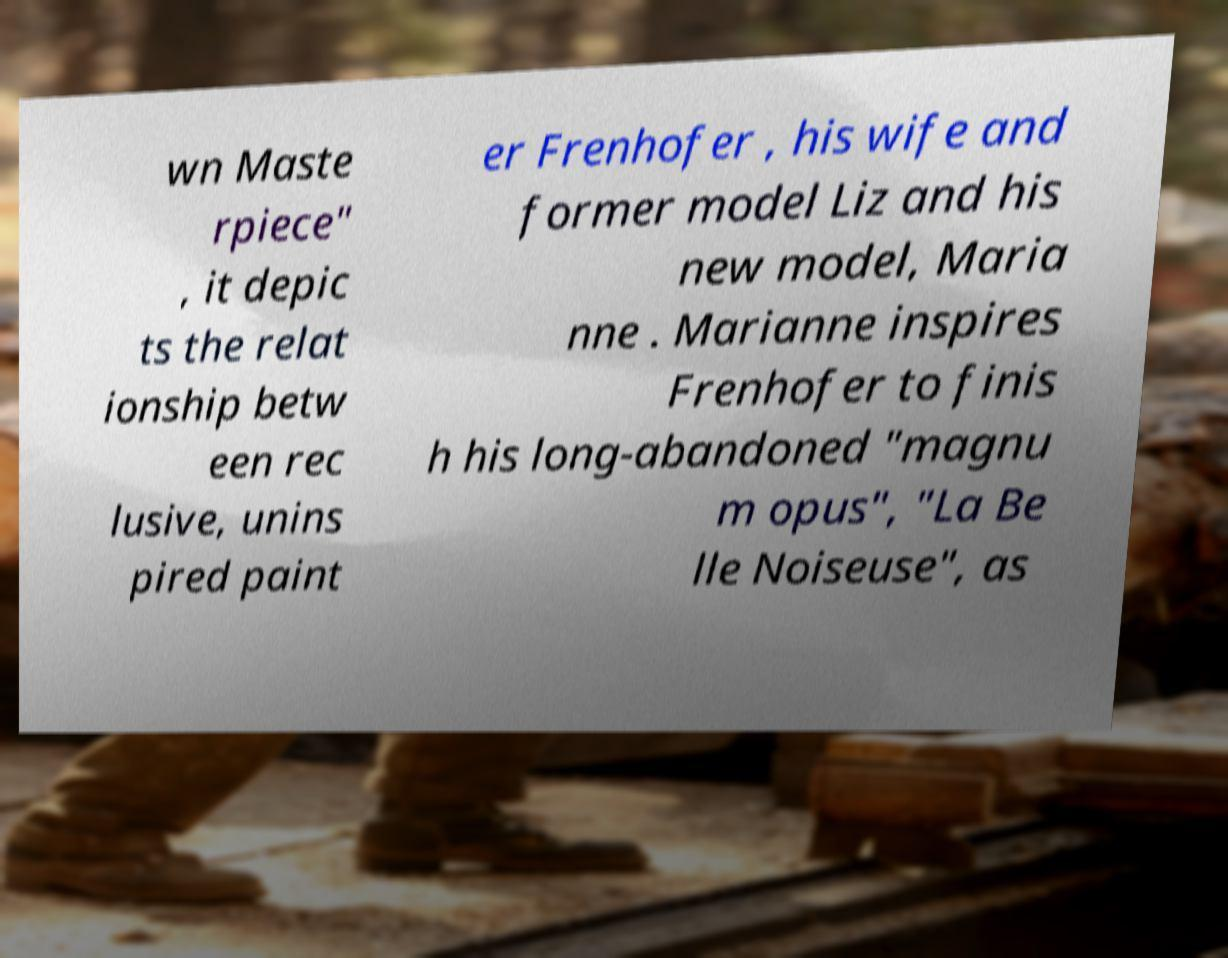Please identify and transcribe the text found in this image. wn Maste rpiece" , it depic ts the relat ionship betw een rec lusive, unins pired paint er Frenhofer , his wife and former model Liz and his new model, Maria nne . Marianne inspires Frenhofer to finis h his long-abandoned "magnu m opus", "La Be lle Noiseuse", as 